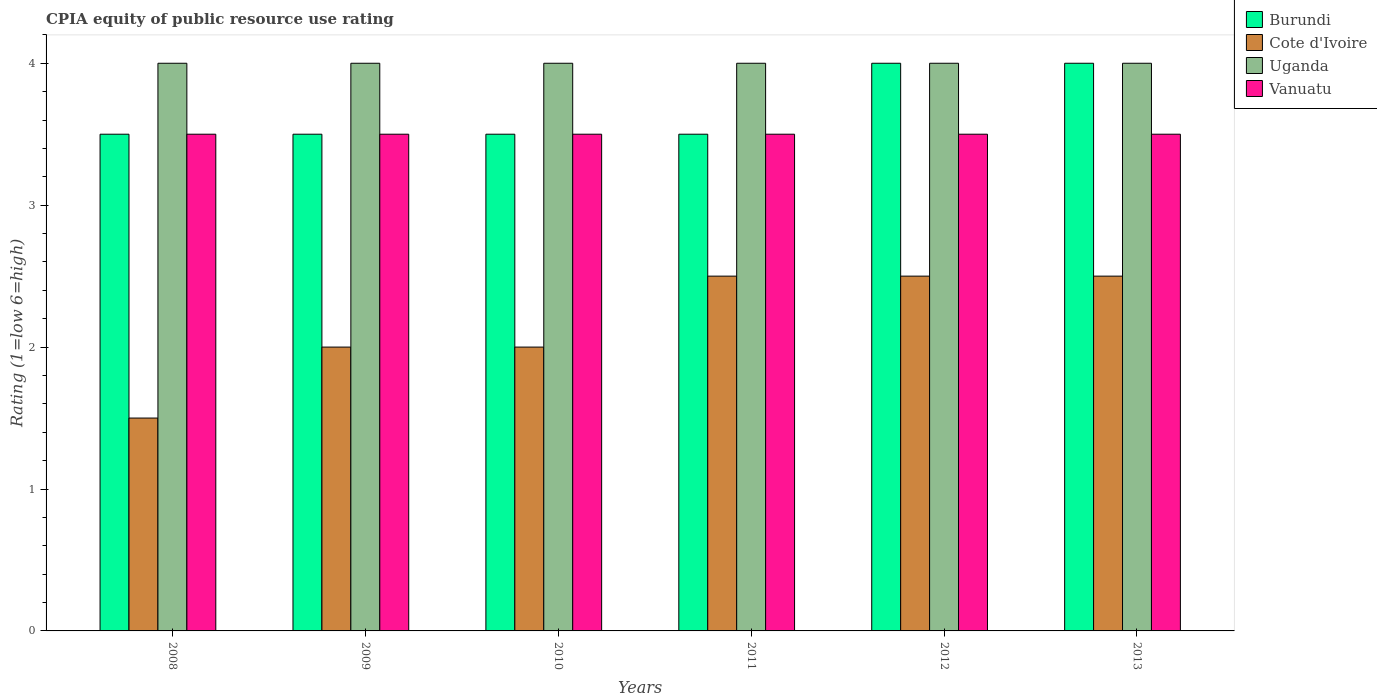How many groups of bars are there?
Your answer should be compact. 6. How many bars are there on the 3rd tick from the left?
Keep it short and to the point. 4. How many bars are there on the 3rd tick from the right?
Provide a succinct answer. 4. What is the label of the 4th group of bars from the left?
Your response must be concise. 2011. In how many cases, is the number of bars for a given year not equal to the number of legend labels?
Give a very brief answer. 0. Across all years, what is the maximum CPIA rating in Vanuatu?
Make the answer very short. 3.5. In which year was the CPIA rating in Burundi maximum?
Your answer should be very brief. 2012. What is the difference between the CPIA rating in Burundi in 2009 and the CPIA rating in Cote d'Ivoire in 2013?
Offer a terse response. 1. What is the average CPIA rating in Uganda per year?
Keep it short and to the point. 4. In how many years, is the CPIA rating in Burundi greater than 2.2?
Your answer should be compact. 6. Is the CPIA rating in Uganda in 2010 less than that in 2011?
Your response must be concise. No. Is the difference between the CPIA rating in Cote d'Ivoire in 2009 and 2012 greater than the difference between the CPIA rating in Burundi in 2009 and 2012?
Keep it short and to the point. No. What is the difference between the highest and the second highest CPIA rating in Burundi?
Give a very brief answer. 0. What is the difference between the highest and the lowest CPIA rating in Cote d'Ivoire?
Your response must be concise. 1. Is the sum of the CPIA rating in Cote d'Ivoire in 2009 and 2013 greater than the maximum CPIA rating in Vanuatu across all years?
Offer a very short reply. Yes. Is it the case that in every year, the sum of the CPIA rating in Vanuatu and CPIA rating in Cote d'Ivoire is greater than the sum of CPIA rating in Uganda and CPIA rating in Burundi?
Make the answer very short. No. What does the 4th bar from the left in 2009 represents?
Your response must be concise. Vanuatu. What does the 1st bar from the right in 2013 represents?
Your answer should be compact. Vanuatu. How many bars are there?
Your answer should be compact. 24. What is the difference between two consecutive major ticks on the Y-axis?
Keep it short and to the point. 1. Does the graph contain any zero values?
Ensure brevity in your answer.  No. Does the graph contain grids?
Keep it short and to the point. No. How many legend labels are there?
Offer a terse response. 4. What is the title of the graph?
Offer a very short reply. CPIA equity of public resource use rating. What is the label or title of the X-axis?
Your answer should be compact. Years. What is the label or title of the Y-axis?
Provide a short and direct response. Rating (1=low 6=high). What is the Rating (1=low 6=high) in Burundi in 2008?
Provide a short and direct response. 3.5. What is the Rating (1=low 6=high) of Cote d'Ivoire in 2008?
Offer a very short reply. 1.5. What is the Rating (1=low 6=high) in Uganda in 2008?
Offer a terse response. 4. What is the Rating (1=low 6=high) in Vanuatu in 2008?
Keep it short and to the point. 3.5. What is the Rating (1=low 6=high) in Burundi in 2009?
Keep it short and to the point. 3.5. What is the Rating (1=low 6=high) in Cote d'Ivoire in 2009?
Keep it short and to the point. 2. What is the Rating (1=low 6=high) in Vanuatu in 2009?
Your answer should be very brief. 3.5. What is the Rating (1=low 6=high) in Cote d'Ivoire in 2010?
Make the answer very short. 2. What is the Rating (1=low 6=high) in Vanuatu in 2010?
Offer a very short reply. 3.5. What is the Rating (1=low 6=high) in Uganda in 2011?
Your answer should be very brief. 4. What is the Rating (1=low 6=high) in Cote d'Ivoire in 2012?
Your answer should be compact. 2.5. What is the Rating (1=low 6=high) of Uganda in 2012?
Keep it short and to the point. 4. What is the Rating (1=low 6=high) of Burundi in 2013?
Offer a very short reply. 4. What is the Rating (1=low 6=high) in Cote d'Ivoire in 2013?
Your answer should be compact. 2.5. What is the Rating (1=low 6=high) of Uganda in 2013?
Provide a short and direct response. 4. What is the Rating (1=low 6=high) of Vanuatu in 2013?
Your answer should be very brief. 3.5. Across all years, what is the maximum Rating (1=low 6=high) of Burundi?
Offer a very short reply. 4. Across all years, what is the maximum Rating (1=low 6=high) in Cote d'Ivoire?
Offer a very short reply. 2.5. Across all years, what is the maximum Rating (1=low 6=high) in Uganda?
Provide a succinct answer. 4. Across all years, what is the minimum Rating (1=low 6=high) of Burundi?
Provide a short and direct response. 3.5. Across all years, what is the minimum Rating (1=low 6=high) of Cote d'Ivoire?
Keep it short and to the point. 1.5. What is the total Rating (1=low 6=high) of Burundi in the graph?
Give a very brief answer. 22. What is the total Rating (1=low 6=high) of Cote d'Ivoire in the graph?
Give a very brief answer. 13. What is the total Rating (1=low 6=high) of Vanuatu in the graph?
Your answer should be very brief. 21. What is the difference between the Rating (1=low 6=high) of Burundi in 2008 and that in 2009?
Keep it short and to the point. 0. What is the difference between the Rating (1=low 6=high) of Uganda in 2008 and that in 2009?
Make the answer very short. 0. What is the difference between the Rating (1=low 6=high) of Vanuatu in 2008 and that in 2009?
Your response must be concise. 0. What is the difference between the Rating (1=low 6=high) in Burundi in 2008 and that in 2010?
Offer a very short reply. 0. What is the difference between the Rating (1=low 6=high) of Cote d'Ivoire in 2008 and that in 2010?
Your response must be concise. -0.5. What is the difference between the Rating (1=low 6=high) of Vanuatu in 2008 and that in 2010?
Keep it short and to the point. 0. What is the difference between the Rating (1=low 6=high) in Cote d'Ivoire in 2008 and that in 2011?
Ensure brevity in your answer.  -1. What is the difference between the Rating (1=low 6=high) of Vanuatu in 2008 and that in 2011?
Make the answer very short. 0. What is the difference between the Rating (1=low 6=high) of Burundi in 2008 and that in 2012?
Offer a terse response. -0.5. What is the difference between the Rating (1=low 6=high) of Vanuatu in 2008 and that in 2012?
Provide a succinct answer. 0. What is the difference between the Rating (1=low 6=high) of Burundi in 2008 and that in 2013?
Your answer should be compact. -0.5. What is the difference between the Rating (1=low 6=high) in Uganda in 2008 and that in 2013?
Make the answer very short. 0. What is the difference between the Rating (1=low 6=high) of Vanuatu in 2008 and that in 2013?
Ensure brevity in your answer.  0. What is the difference between the Rating (1=low 6=high) in Burundi in 2009 and that in 2010?
Keep it short and to the point. 0. What is the difference between the Rating (1=low 6=high) of Uganda in 2009 and that in 2010?
Offer a very short reply. 0. What is the difference between the Rating (1=low 6=high) in Burundi in 2009 and that in 2011?
Offer a very short reply. 0. What is the difference between the Rating (1=low 6=high) in Uganda in 2009 and that in 2011?
Offer a very short reply. 0. What is the difference between the Rating (1=low 6=high) of Cote d'Ivoire in 2009 and that in 2012?
Give a very brief answer. -0.5. What is the difference between the Rating (1=low 6=high) in Uganda in 2009 and that in 2012?
Ensure brevity in your answer.  0. What is the difference between the Rating (1=low 6=high) in Burundi in 2009 and that in 2013?
Make the answer very short. -0.5. What is the difference between the Rating (1=low 6=high) in Cote d'Ivoire in 2009 and that in 2013?
Offer a very short reply. -0.5. What is the difference between the Rating (1=low 6=high) of Uganda in 2009 and that in 2013?
Your answer should be compact. 0. What is the difference between the Rating (1=low 6=high) in Vanuatu in 2009 and that in 2013?
Your answer should be very brief. 0. What is the difference between the Rating (1=low 6=high) of Burundi in 2010 and that in 2011?
Provide a short and direct response. 0. What is the difference between the Rating (1=low 6=high) of Uganda in 2010 and that in 2012?
Offer a very short reply. 0. What is the difference between the Rating (1=low 6=high) in Burundi in 2011 and that in 2012?
Your answer should be very brief. -0.5. What is the difference between the Rating (1=low 6=high) in Vanuatu in 2011 and that in 2012?
Provide a short and direct response. 0. What is the difference between the Rating (1=low 6=high) in Burundi in 2011 and that in 2013?
Your answer should be very brief. -0.5. What is the difference between the Rating (1=low 6=high) of Uganda in 2011 and that in 2013?
Your answer should be compact. 0. What is the difference between the Rating (1=low 6=high) of Cote d'Ivoire in 2012 and that in 2013?
Keep it short and to the point. 0. What is the difference between the Rating (1=low 6=high) of Vanuatu in 2012 and that in 2013?
Offer a terse response. 0. What is the difference between the Rating (1=low 6=high) of Burundi in 2008 and the Rating (1=low 6=high) of Cote d'Ivoire in 2009?
Give a very brief answer. 1.5. What is the difference between the Rating (1=low 6=high) of Burundi in 2008 and the Rating (1=low 6=high) of Uganda in 2009?
Make the answer very short. -0.5. What is the difference between the Rating (1=low 6=high) in Cote d'Ivoire in 2008 and the Rating (1=low 6=high) in Uganda in 2009?
Ensure brevity in your answer.  -2.5. What is the difference between the Rating (1=low 6=high) of Cote d'Ivoire in 2008 and the Rating (1=low 6=high) of Vanuatu in 2009?
Offer a terse response. -2. What is the difference between the Rating (1=low 6=high) of Uganda in 2008 and the Rating (1=low 6=high) of Vanuatu in 2009?
Offer a very short reply. 0.5. What is the difference between the Rating (1=low 6=high) of Burundi in 2008 and the Rating (1=low 6=high) of Cote d'Ivoire in 2010?
Offer a terse response. 1.5. What is the difference between the Rating (1=low 6=high) of Burundi in 2008 and the Rating (1=low 6=high) of Uganda in 2010?
Make the answer very short. -0.5. What is the difference between the Rating (1=low 6=high) of Cote d'Ivoire in 2008 and the Rating (1=low 6=high) of Uganda in 2010?
Make the answer very short. -2.5. What is the difference between the Rating (1=low 6=high) in Cote d'Ivoire in 2008 and the Rating (1=low 6=high) in Vanuatu in 2010?
Offer a terse response. -2. What is the difference between the Rating (1=low 6=high) of Burundi in 2008 and the Rating (1=low 6=high) of Vanuatu in 2011?
Your response must be concise. 0. What is the difference between the Rating (1=low 6=high) in Cote d'Ivoire in 2008 and the Rating (1=low 6=high) in Uganda in 2011?
Your response must be concise. -2.5. What is the difference between the Rating (1=low 6=high) in Uganda in 2008 and the Rating (1=low 6=high) in Vanuatu in 2011?
Offer a very short reply. 0.5. What is the difference between the Rating (1=low 6=high) of Cote d'Ivoire in 2008 and the Rating (1=low 6=high) of Uganda in 2012?
Make the answer very short. -2.5. What is the difference between the Rating (1=low 6=high) in Cote d'Ivoire in 2008 and the Rating (1=low 6=high) in Vanuatu in 2012?
Make the answer very short. -2. What is the difference between the Rating (1=low 6=high) in Uganda in 2008 and the Rating (1=low 6=high) in Vanuatu in 2012?
Offer a very short reply. 0.5. What is the difference between the Rating (1=low 6=high) of Burundi in 2008 and the Rating (1=low 6=high) of Cote d'Ivoire in 2013?
Offer a terse response. 1. What is the difference between the Rating (1=low 6=high) in Burundi in 2008 and the Rating (1=low 6=high) in Uganda in 2013?
Give a very brief answer. -0.5. What is the difference between the Rating (1=low 6=high) in Cote d'Ivoire in 2008 and the Rating (1=low 6=high) in Vanuatu in 2013?
Provide a short and direct response. -2. What is the difference between the Rating (1=low 6=high) of Burundi in 2009 and the Rating (1=low 6=high) of Vanuatu in 2011?
Offer a terse response. 0. What is the difference between the Rating (1=low 6=high) in Cote d'Ivoire in 2009 and the Rating (1=low 6=high) in Uganda in 2011?
Provide a succinct answer. -2. What is the difference between the Rating (1=low 6=high) in Cote d'Ivoire in 2009 and the Rating (1=low 6=high) in Vanuatu in 2011?
Offer a very short reply. -1.5. What is the difference between the Rating (1=low 6=high) of Burundi in 2009 and the Rating (1=low 6=high) of Vanuatu in 2012?
Your response must be concise. 0. What is the difference between the Rating (1=low 6=high) in Cote d'Ivoire in 2009 and the Rating (1=low 6=high) in Uganda in 2012?
Your answer should be compact. -2. What is the difference between the Rating (1=low 6=high) in Burundi in 2009 and the Rating (1=low 6=high) in Cote d'Ivoire in 2013?
Your answer should be very brief. 1. What is the difference between the Rating (1=low 6=high) in Burundi in 2009 and the Rating (1=low 6=high) in Uganda in 2013?
Give a very brief answer. -0.5. What is the difference between the Rating (1=low 6=high) in Burundi in 2009 and the Rating (1=low 6=high) in Vanuatu in 2013?
Ensure brevity in your answer.  0. What is the difference between the Rating (1=low 6=high) of Burundi in 2010 and the Rating (1=low 6=high) of Uganda in 2011?
Make the answer very short. -0.5. What is the difference between the Rating (1=low 6=high) in Burundi in 2010 and the Rating (1=low 6=high) in Vanuatu in 2011?
Offer a terse response. 0. What is the difference between the Rating (1=low 6=high) in Cote d'Ivoire in 2010 and the Rating (1=low 6=high) in Vanuatu in 2011?
Offer a terse response. -1.5. What is the difference between the Rating (1=low 6=high) of Burundi in 2010 and the Rating (1=low 6=high) of Cote d'Ivoire in 2012?
Give a very brief answer. 1. What is the difference between the Rating (1=low 6=high) in Cote d'Ivoire in 2010 and the Rating (1=low 6=high) in Vanuatu in 2012?
Offer a very short reply. -1.5. What is the difference between the Rating (1=low 6=high) of Uganda in 2010 and the Rating (1=low 6=high) of Vanuatu in 2012?
Offer a very short reply. 0.5. What is the difference between the Rating (1=low 6=high) of Burundi in 2010 and the Rating (1=low 6=high) of Cote d'Ivoire in 2013?
Make the answer very short. 1. What is the difference between the Rating (1=low 6=high) of Burundi in 2010 and the Rating (1=low 6=high) of Vanuatu in 2013?
Ensure brevity in your answer.  0. What is the difference between the Rating (1=low 6=high) in Cote d'Ivoire in 2010 and the Rating (1=low 6=high) in Uganda in 2013?
Keep it short and to the point. -2. What is the difference between the Rating (1=low 6=high) of Uganda in 2010 and the Rating (1=low 6=high) of Vanuatu in 2013?
Your response must be concise. 0.5. What is the difference between the Rating (1=low 6=high) of Burundi in 2011 and the Rating (1=low 6=high) of Vanuatu in 2012?
Your answer should be compact. 0. What is the difference between the Rating (1=low 6=high) of Cote d'Ivoire in 2011 and the Rating (1=low 6=high) of Uganda in 2012?
Provide a succinct answer. -1.5. What is the difference between the Rating (1=low 6=high) in Cote d'Ivoire in 2011 and the Rating (1=low 6=high) in Vanuatu in 2012?
Your answer should be compact. -1. What is the difference between the Rating (1=low 6=high) in Burundi in 2011 and the Rating (1=low 6=high) in Vanuatu in 2013?
Provide a short and direct response. 0. What is the difference between the Rating (1=low 6=high) in Cote d'Ivoire in 2011 and the Rating (1=low 6=high) in Vanuatu in 2013?
Make the answer very short. -1. What is the difference between the Rating (1=low 6=high) in Uganda in 2011 and the Rating (1=low 6=high) in Vanuatu in 2013?
Give a very brief answer. 0.5. What is the difference between the Rating (1=low 6=high) in Burundi in 2012 and the Rating (1=low 6=high) in Vanuatu in 2013?
Your answer should be very brief. 0.5. What is the average Rating (1=low 6=high) of Burundi per year?
Provide a short and direct response. 3.67. What is the average Rating (1=low 6=high) of Cote d'Ivoire per year?
Offer a terse response. 2.17. What is the average Rating (1=low 6=high) of Vanuatu per year?
Your response must be concise. 3.5. In the year 2008, what is the difference between the Rating (1=low 6=high) in Burundi and Rating (1=low 6=high) in Uganda?
Keep it short and to the point. -0.5. In the year 2008, what is the difference between the Rating (1=low 6=high) in Burundi and Rating (1=low 6=high) in Vanuatu?
Give a very brief answer. 0. In the year 2009, what is the difference between the Rating (1=low 6=high) in Burundi and Rating (1=low 6=high) in Uganda?
Your answer should be very brief. -0.5. In the year 2009, what is the difference between the Rating (1=low 6=high) in Burundi and Rating (1=low 6=high) in Vanuatu?
Provide a short and direct response. 0. In the year 2010, what is the difference between the Rating (1=low 6=high) in Burundi and Rating (1=low 6=high) in Cote d'Ivoire?
Your response must be concise. 1.5. In the year 2010, what is the difference between the Rating (1=low 6=high) in Burundi and Rating (1=low 6=high) in Uganda?
Provide a succinct answer. -0.5. In the year 2010, what is the difference between the Rating (1=low 6=high) in Burundi and Rating (1=low 6=high) in Vanuatu?
Offer a very short reply. 0. In the year 2010, what is the difference between the Rating (1=low 6=high) of Cote d'Ivoire and Rating (1=low 6=high) of Uganda?
Your response must be concise. -2. In the year 2010, what is the difference between the Rating (1=low 6=high) of Cote d'Ivoire and Rating (1=low 6=high) of Vanuatu?
Keep it short and to the point. -1.5. In the year 2010, what is the difference between the Rating (1=low 6=high) of Uganda and Rating (1=low 6=high) of Vanuatu?
Your answer should be very brief. 0.5. In the year 2011, what is the difference between the Rating (1=low 6=high) of Burundi and Rating (1=low 6=high) of Vanuatu?
Ensure brevity in your answer.  0. In the year 2011, what is the difference between the Rating (1=low 6=high) of Cote d'Ivoire and Rating (1=low 6=high) of Uganda?
Give a very brief answer. -1.5. In the year 2011, what is the difference between the Rating (1=low 6=high) in Uganda and Rating (1=low 6=high) in Vanuatu?
Provide a succinct answer. 0.5. In the year 2012, what is the difference between the Rating (1=low 6=high) in Burundi and Rating (1=low 6=high) in Cote d'Ivoire?
Give a very brief answer. 1.5. In the year 2012, what is the difference between the Rating (1=low 6=high) of Burundi and Rating (1=low 6=high) of Vanuatu?
Your response must be concise. 0.5. In the year 2012, what is the difference between the Rating (1=low 6=high) of Cote d'Ivoire and Rating (1=low 6=high) of Vanuatu?
Your answer should be compact. -1. In the year 2012, what is the difference between the Rating (1=low 6=high) in Uganda and Rating (1=low 6=high) in Vanuatu?
Give a very brief answer. 0.5. In the year 2013, what is the difference between the Rating (1=low 6=high) of Burundi and Rating (1=low 6=high) of Uganda?
Offer a terse response. 0. In the year 2013, what is the difference between the Rating (1=low 6=high) of Burundi and Rating (1=low 6=high) of Vanuatu?
Offer a very short reply. 0.5. In the year 2013, what is the difference between the Rating (1=low 6=high) of Cote d'Ivoire and Rating (1=low 6=high) of Uganda?
Your answer should be compact. -1.5. In the year 2013, what is the difference between the Rating (1=low 6=high) of Uganda and Rating (1=low 6=high) of Vanuatu?
Provide a short and direct response. 0.5. What is the ratio of the Rating (1=low 6=high) of Vanuatu in 2008 to that in 2009?
Give a very brief answer. 1. What is the ratio of the Rating (1=low 6=high) of Burundi in 2008 to that in 2010?
Keep it short and to the point. 1. What is the ratio of the Rating (1=low 6=high) of Cote d'Ivoire in 2008 to that in 2010?
Your response must be concise. 0.75. What is the ratio of the Rating (1=low 6=high) in Burundi in 2008 to that in 2011?
Offer a very short reply. 1. What is the ratio of the Rating (1=low 6=high) in Cote d'Ivoire in 2008 to that in 2011?
Provide a short and direct response. 0.6. What is the ratio of the Rating (1=low 6=high) in Uganda in 2008 to that in 2011?
Offer a terse response. 1. What is the ratio of the Rating (1=low 6=high) in Vanuatu in 2008 to that in 2011?
Provide a short and direct response. 1. What is the ratio of the Rating (1=low 6=high) of Uganda in 2008 to that in 2012?
Provide a short and direct response. 1. What is the ratio of the Rating (1=low 6=high) in Vanuatu in 2008 to that in 2012?
Your response must be concise. 1. What is the ratio of the Rating (1=low 6=high) of Cote d'Ivoire in 2008 to that in 2013?
Keep it short and to the point. 0.6. What is the ratio of the Rating (1=low 6=high) of Burundi in 2009 to that in 2010?
Your answer should be compact. 1. What is the ratio of the Rating (1=low 6=high) of Cote d'Ivoire in 2009 to that in 2010?
Keep it short and to the point. 1. What is the ratio of the Rating (1=low 6=high) in Vanuatu in 2009 to that in 2010?
Your answer should be very brief. 1. What is the ratio of the Rating (1=low 6=high) in Uganda in 2009 to that in 2011?
Keep it short and to the point. 1. What is the ratio of the Rating (1=low 6=high) of Vanuatu in 2009 to that in 2011?
Offer a very short reply. 1. What is the ratio of the Rating (1=low 6=high) in Uganda in 2009 to that in 2012?
Offer a terse response. 1. What is the ratio of the Rating (1=low 6=high) of Vanuatu in 2009 to that in 2012?
Your answer should be compact. 1. What is the ratio of the Rating (1=low 6=high) of Uganda in 2009 to that in 2013?
Keep it short and to the point. 1. What is the ratio of the Rating (1=low 6=high) in Vanuatu in 2009 to that in 2013?
Your answer should be very brief. 1. What is the ratio of the Rating (1=low 6=high) in Cote d'Ivoire in 2010 to that in 2011?
Your answer should be very brief. 0.8. What is the ratio of the Rating (1=low 6=high) of Uganda in 2010 to that in 2011?
Provide a succinct answer. 1. What is the ratio of the Rating (1=low 6=high) in Cote d'Ivoire in 2010 to that in 2013?
Provide a short and direct response. 0.8. What is the ratio of the Rating (1=low 6=high) of Uganda in 2010 to that in 2013?
Offer a very short reply. 1. What is the ratio of the Rating (1=low 6=high) in Vanuatu in 2011 to that in 2012?
Provide a short and direct response. 1. What is the ratio of the Rating (1=low 6=high) in Burundi in 2012 to that in 2013?
Make the answer very short. 1. What is the ratio of the Rating (1=low 6=high) of Vanuatu in 2012 to that in 2013?
Your response must be concise. 1. What is the difference between the highest and the second highest Rating (1=low 6=high) in Cote d'Ivoire?
Your answer should be compact. 0. What is the difference between the highest and the second highest Rating (1=low 6=high) of Vanuatu?
Provide a short and direct response. 0. What is the difference between the highest and the lowest Rating (1=low 6=high) of Burundi?
Provide a succinct answer. 0.5. What is the difference between the highest and the lowest Rating (1=low 6=high) in Cote d'Ivoire?
Provide a succinct answer. 1. What is the difference between the highest and the lowest Rating (1=low 6=high) in Vanuatu?
Keep it short and to the point. 0. 